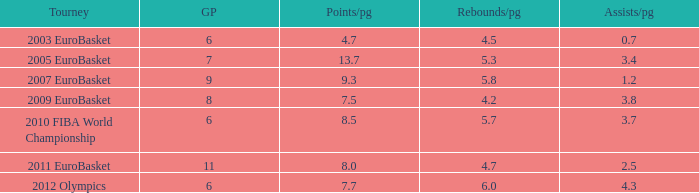How many assists per game in the tournament 2010 fiba world championship? 3.7. 